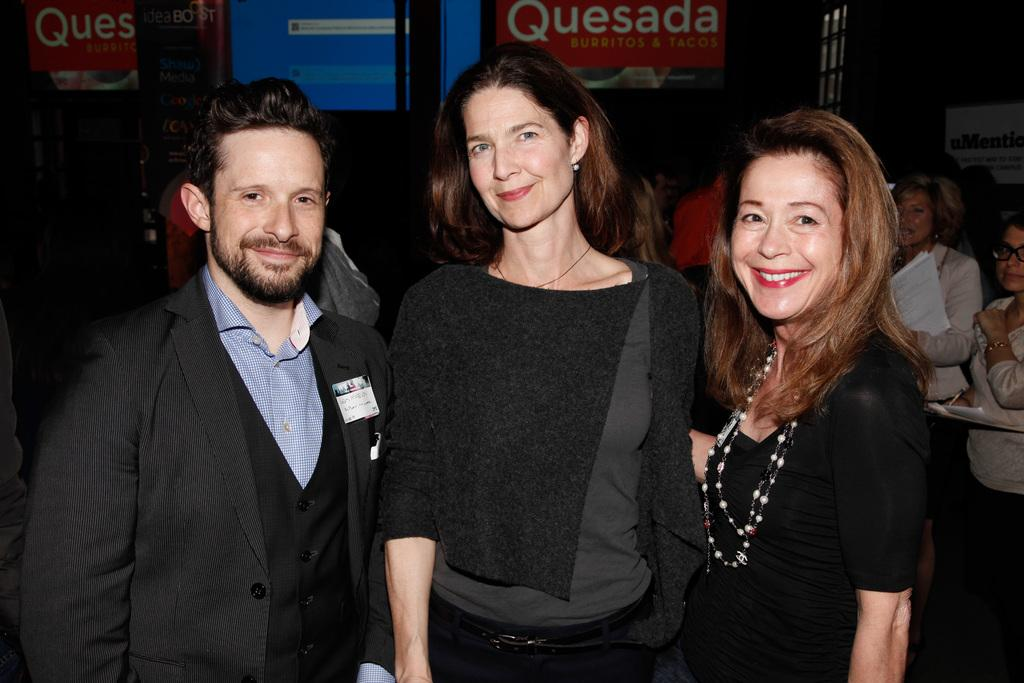How many people are in the foreground of the image? There are three persons standing in the foreground of the image. Can you describe the background of the image? There are people and advertisement boards in the background of the image. What type of cracker is being advertised on the card in the image? There is no card or cracker present in the image; it only features three persons in the foreground and people and advertisement boards in the background. 